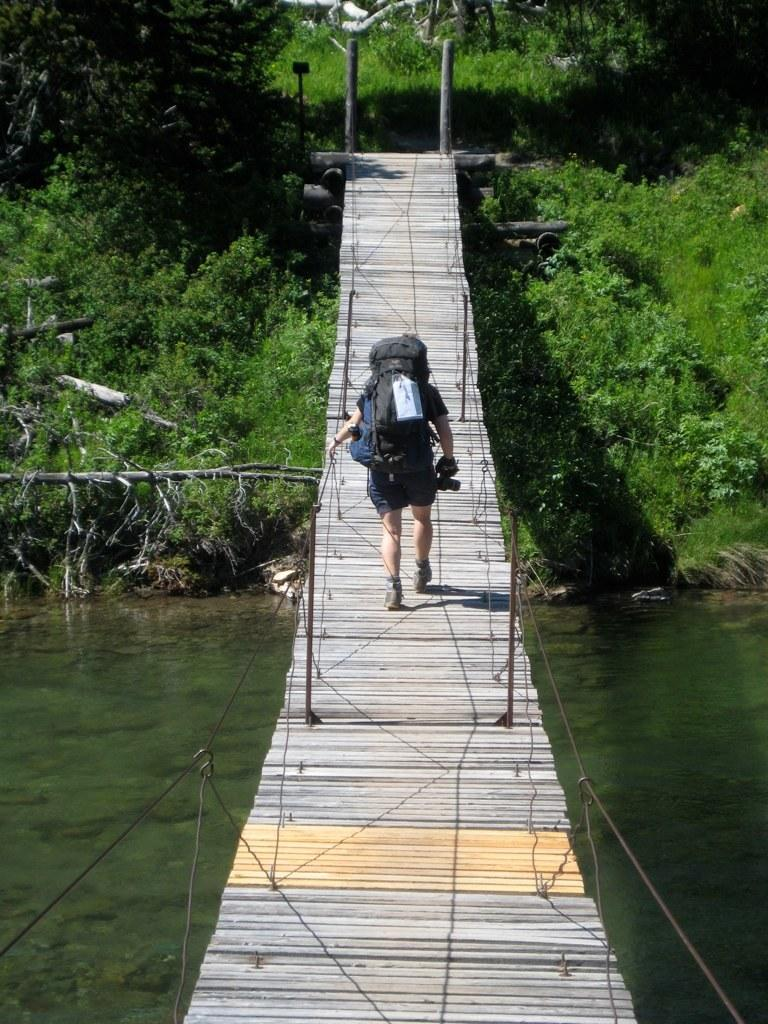What is the main subject in the foreground of the image? There is a rope bridge in the foreground of the image. What is the rope bridge positioned over? The rope bridge is over water. What is the man wearing on the rope bridge doing? A man wearing a backpack is walking on the rope bridge. What can be seen in the background of the image? There are plants and trees in the background of the image. What type of writing can be seen on the tree in the image? There is no tree present in the image, and therefore no writing can be seen on it. How many flocks of birds are visible in the image? There are no birds visible in the image, so it is not possible to determine the number of flocks. 